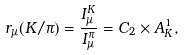<formula> <loc_0><loc_0><loc_500><loc_500>r _ { \mu } ( K / \pi ) = \frac { I _ { \mu } ^ { K } } { I _ { \mu } ^ { \pi } } = C _ { 2 } \times A ^ { 1 } _ { K } ,</formula> 